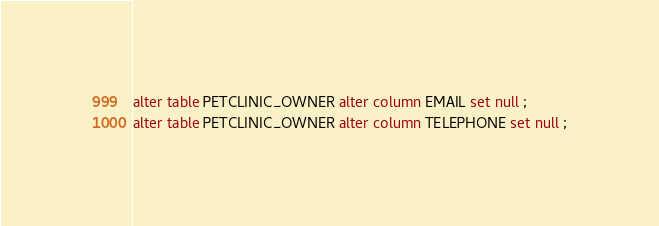Convert code to text. <code><loc_0><loc_0><loc_500><loc_500><_SQL_>alter table PETCLINIC_OWNER alter column EMAIL set null ;
alter table PETCLINIC_OWNER alter column TELEPHONE set null ;
</code> 